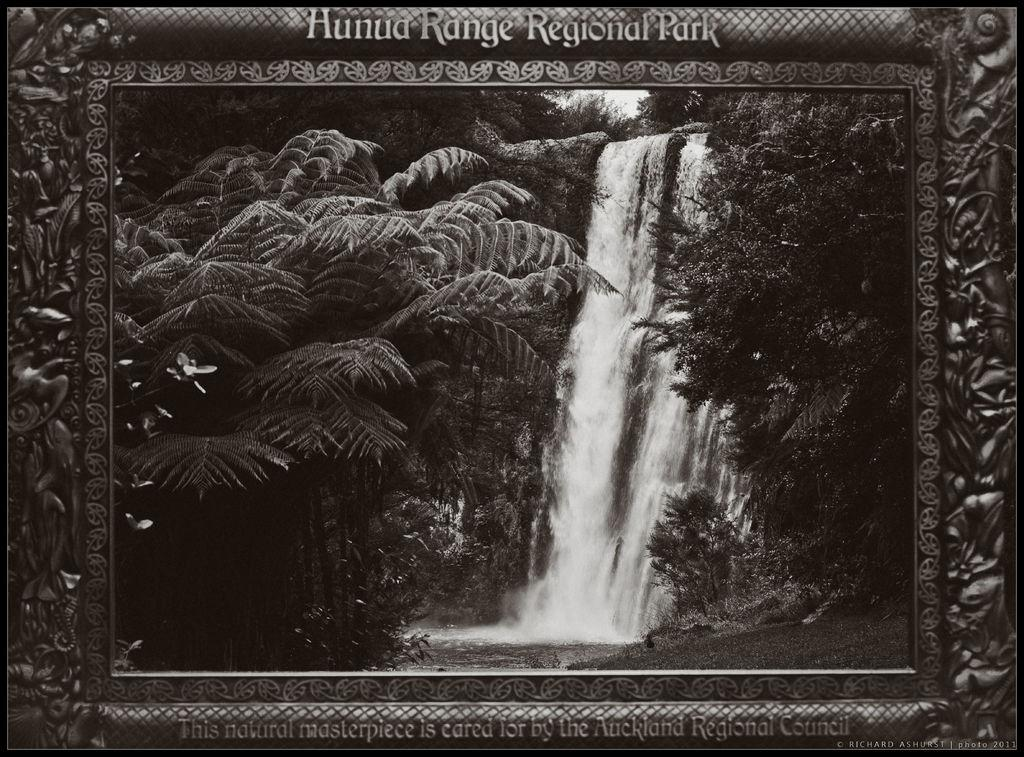What type of natural features can be seen in the image? There are trees, a waterfall, and a mountain in the image. What is visible in the background of the image? The sky is visible in the image. How is the image presented? The image appears to be in a photo frame. What color is the star in the image? There is no star present in the image. What tool is being used to hammer the mountain in the image? There is no hammer or any tool being used to alter the mountain in the image; it is a natural feature. 